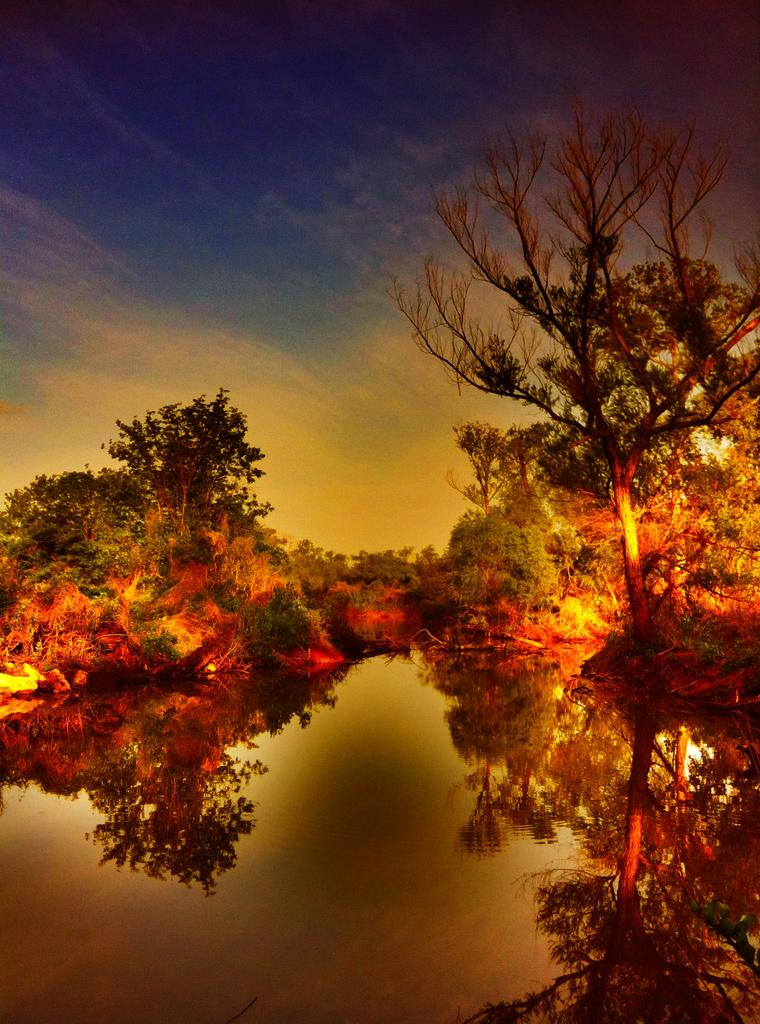What type of vegetation can be seen in the image? There are trees in the image. What is visible in the background of the image? The sky is visible in the image. Can you describe the sky in the image? There are clouds in the sky. What is visible at the bottom of the image? There is water visible at the bottom of the image. What type of wine is being served on the lace tablecloth in the image? There is no wine or tablecloth present in the image; it features trees, sky, clouds, and water. 